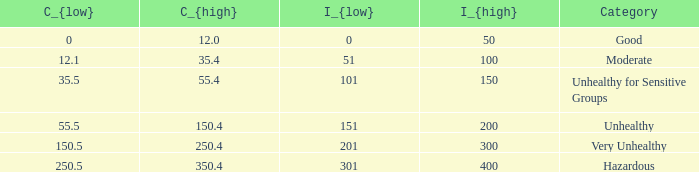In how many different categories is the value of C_{low} 35.5? 1.0. 